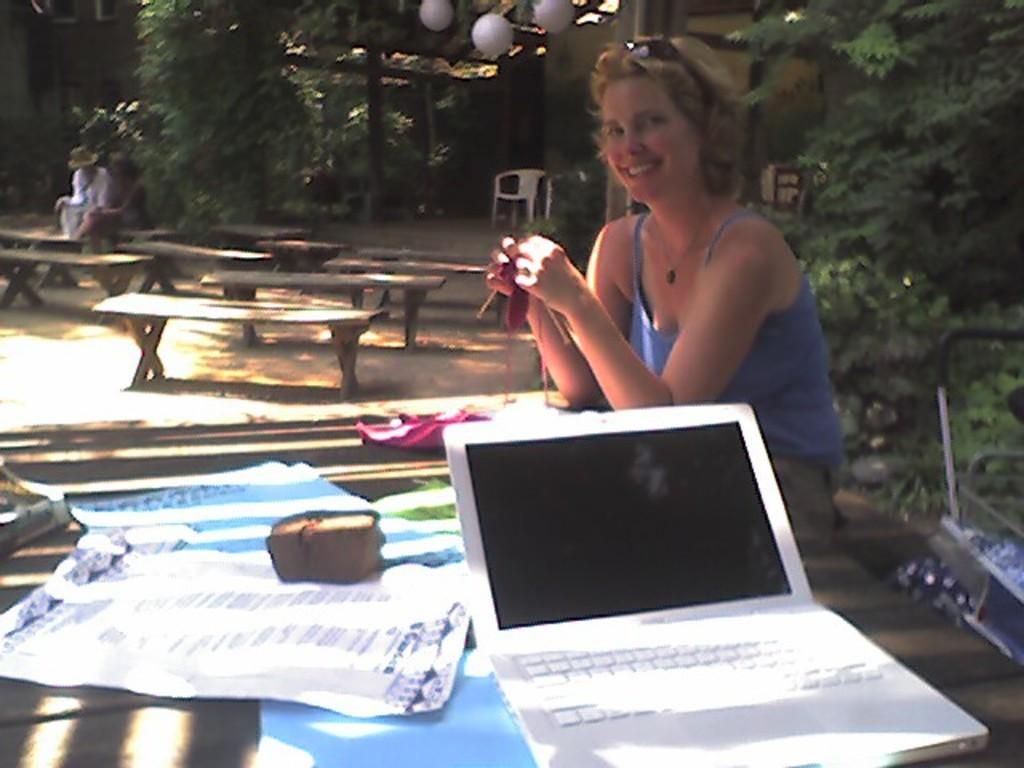Who is present in the image? There is a woman in the image. What is the woman doing in the image? The woman is smiling. What object is on the table in the image? There is a laptop on the table. What can be seen in the background of the image? There are trees and benches in the background of the image. What time of day is it in the image, considering the woman's digestion? There is no information about the time of day or the woman's digestion in the image, so it cannot be determined from the image. 